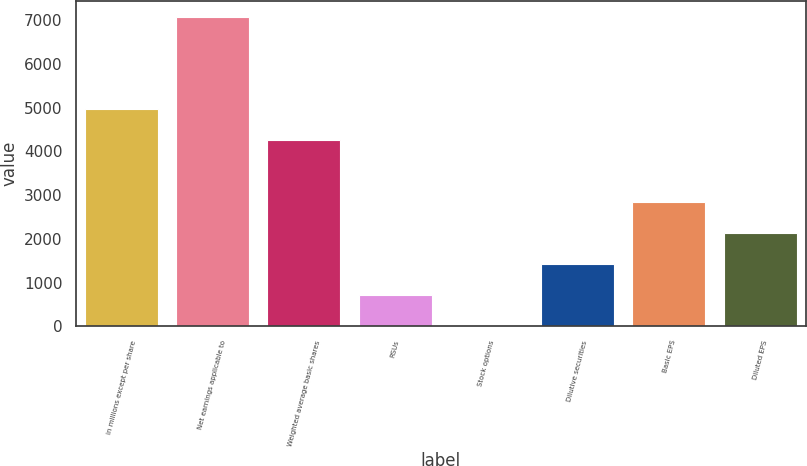Convert chart. <chart><loc_0><loc_0><loc_500><loc_500><bar_chart><fcel>in millions except per share<fcel>Net earnings applicable to<fcel>Weighted average basic shares<fcel>RSUs<fcel>Stock options<fcel>Dilutive securities<fcel>Basic EPS<fcel>Diluted EPS<nl><fcel>4961.8<fcel>7087<fcel>4253.4<fcel>711.4<fcel>3<fcel>1419.8<fcel>2836.6<fcel>2128.2<nl></chart> 